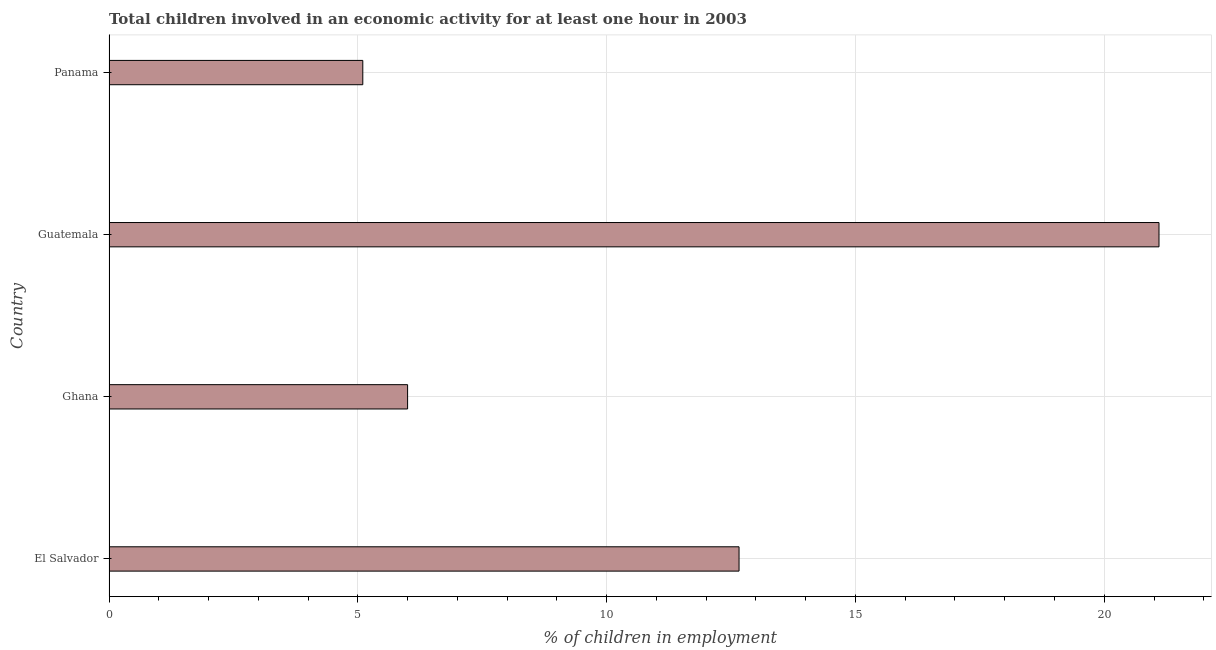Does the graph contain any zero values?
Your answer should be very brief. No. What is the title of the graph?
Your answer should be very brief. Total children involved in an economic activity for at least one hour in 2003. What is the label or title of the X-axis?
Offer a very short reply. % of children in employment. What is the label or title of the Y-axis?
Offer a very short reply. Country. What is the percentage of children in employment in El Salvador?
Your response must be concise. 12.66. Across all countries, what is the maximum percentage of children in employment?
Provide a short and direct response. 21.1. Across all countries, what is the minimum percentage of children in employment?
Offer a very short reply. 5.1. In which country was the percentage of children in employment maximum?
Your answer should be compact. Guatemala. In which country was the percentage of children in employment minimum?
Your answer should be compact. Panama. What is the sum of the percentage of children in employment?
Offer a very short reply. 44.86. What is the difference between the percentage of children in employment in Ghana and Guatemala?
Keep it short and to the point. -15.1. What is the average percentage of children in employment per country?
Your answer should be compact. 11.21. What is the median percentage of children in employment?
Your answer should be very brief. 9.33. What is the ratio of the percentage of children in employment in El Salvador to that in Ghana?
Make the answer very short. 2.11. Is the percentage of children in employment in Guatemala less than that in Panama?
Make the answer very short. No. Is the difference between the percentage of children in employment in Ghana and Panama greater than the difference between any two countries?
Your answer should be very brief. No. What is the difference between the highest and the second highest percentage of children in employment?
Ensure brevity in your answer.  8.44. How many countries are there in the graph?
Give a very brief answer. 4. What is the difference between two consecutive major ticks on the X-axis?
Your answer should be very brief. 5. Are the values on the major ticks of X-axis written in scientific E-notation?
Offer a very short reply. No. What is the % of children in employment in El Salvador?
Offer a terse response. 12.66. What is the % of children in employment of Ghana?
Provide a succinct answer. 6. What is the % of children in employment of Guatemala?
Keep it short and to the point. 21.1. What is the % of children in employment of Panama?
Your answer should be compact. 5.1. What is the difference between the % of children in employment in El Salvador and Ghana?
Provide a short and direct response. 6.66. What is the difference between the % of children in employment in El Salvador and Guatemala?
Provide a short and direct response. -8.44. What is the difference between the % of children in employment in El Salvador and Panama?
Your response must be concise. 7.56. What is the difference between the % of children in employment in Ghana and Guatemala?
Offer a terse response. -15.1. What is the ratio of the % of children in employment in El Salvador to that in Ghana?
Keep it short and to the point. 2.11. What is the ratio of the % of children in employment in El Salvador to that in Panama?
Give a very brief answer. 2.48. What is the ratio of the % of children in employment in Ghana to that in Guatemala?
Your answer should be very brief. 0.28. What is the ratio of the % of children in employment in Ghana to that in Panama?
Ensure brevity in your answer.  1.18. What is the ratio of the % of children in employment in Guatemala to that in Panama?
Provide a succinct answer. 4.14. 